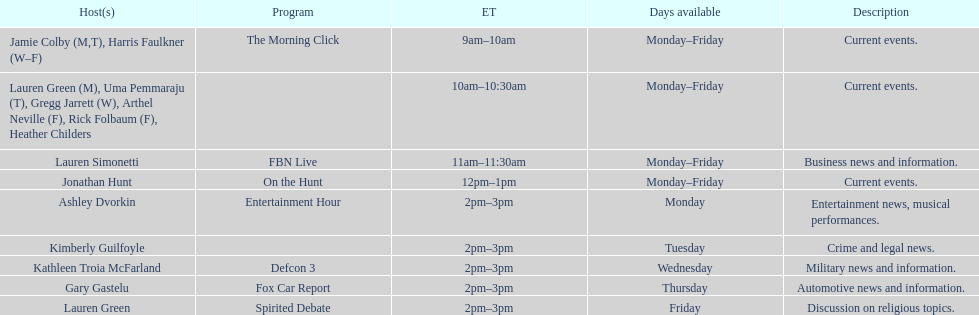How long does the show defcon 3 last? 1 hour. 